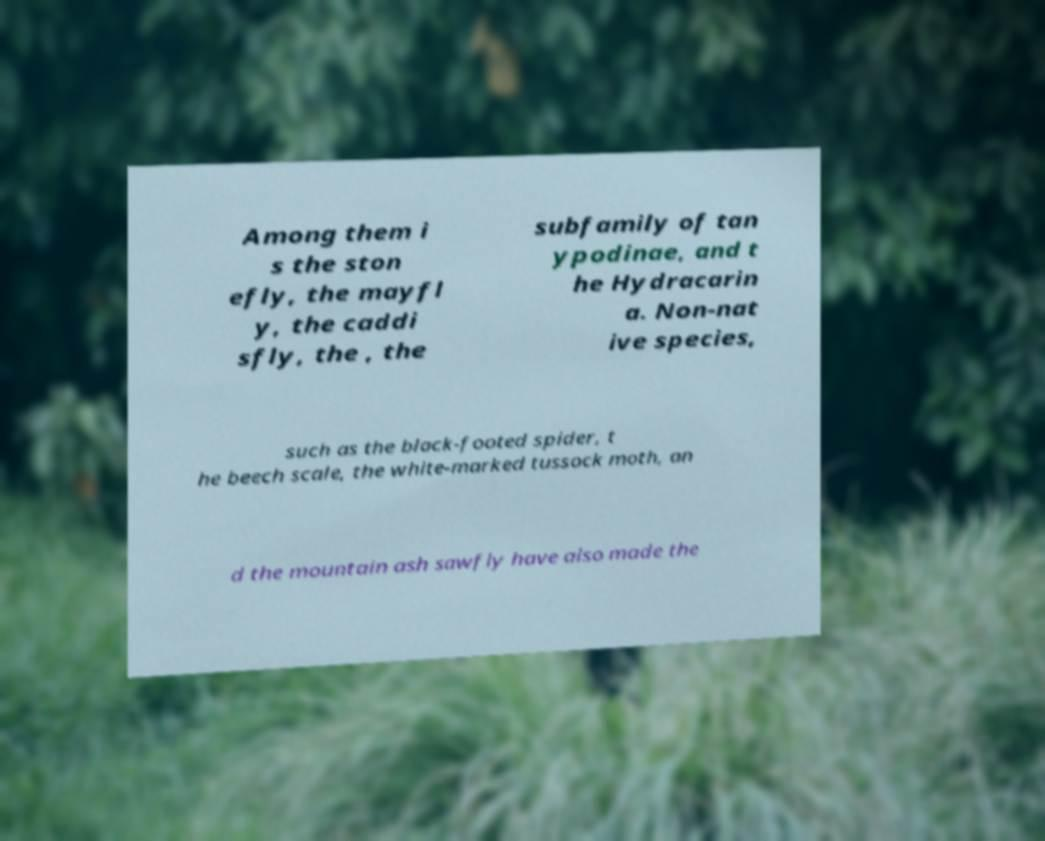Can you accurately transcribe the text from the provided image for me? Among them i s the ston efly, the mayfl y, the caddi sfly, the , the subfamily of tan ypodinae, and t he Hydracarin a. Non-nat ive species, such as the black-footed spider, t he beech scale, the white-marked tussock moth, an d the mountain ash sawfly have also made the 